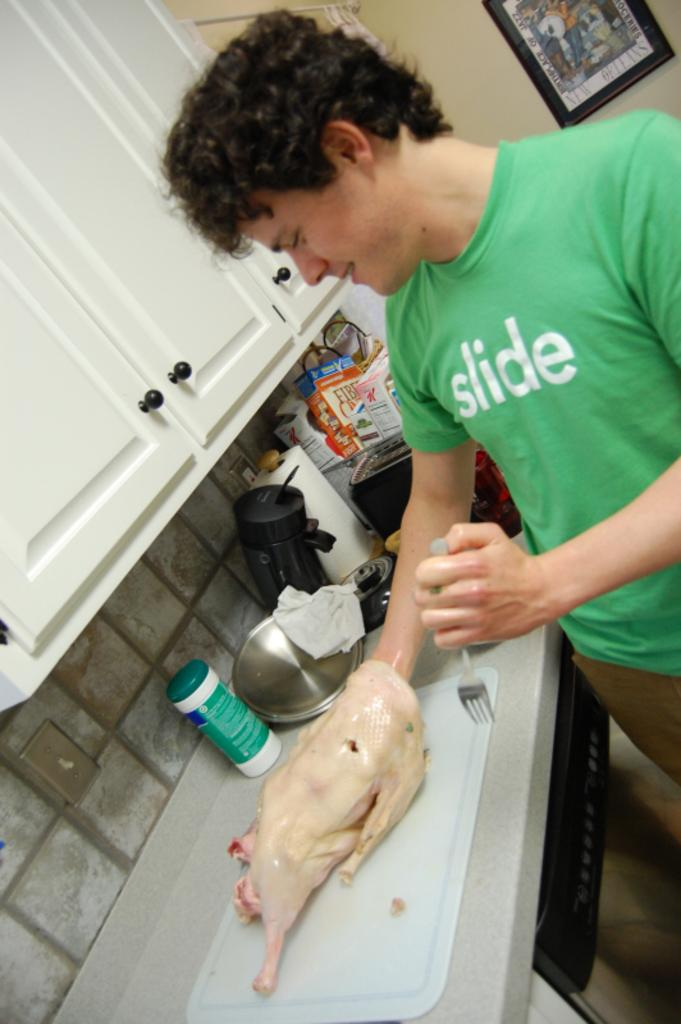<image>
Summarize the visual content of the image. A man in a green shirt with the word slide on it, has his hand inside a chicken, on the kitchen counter. 